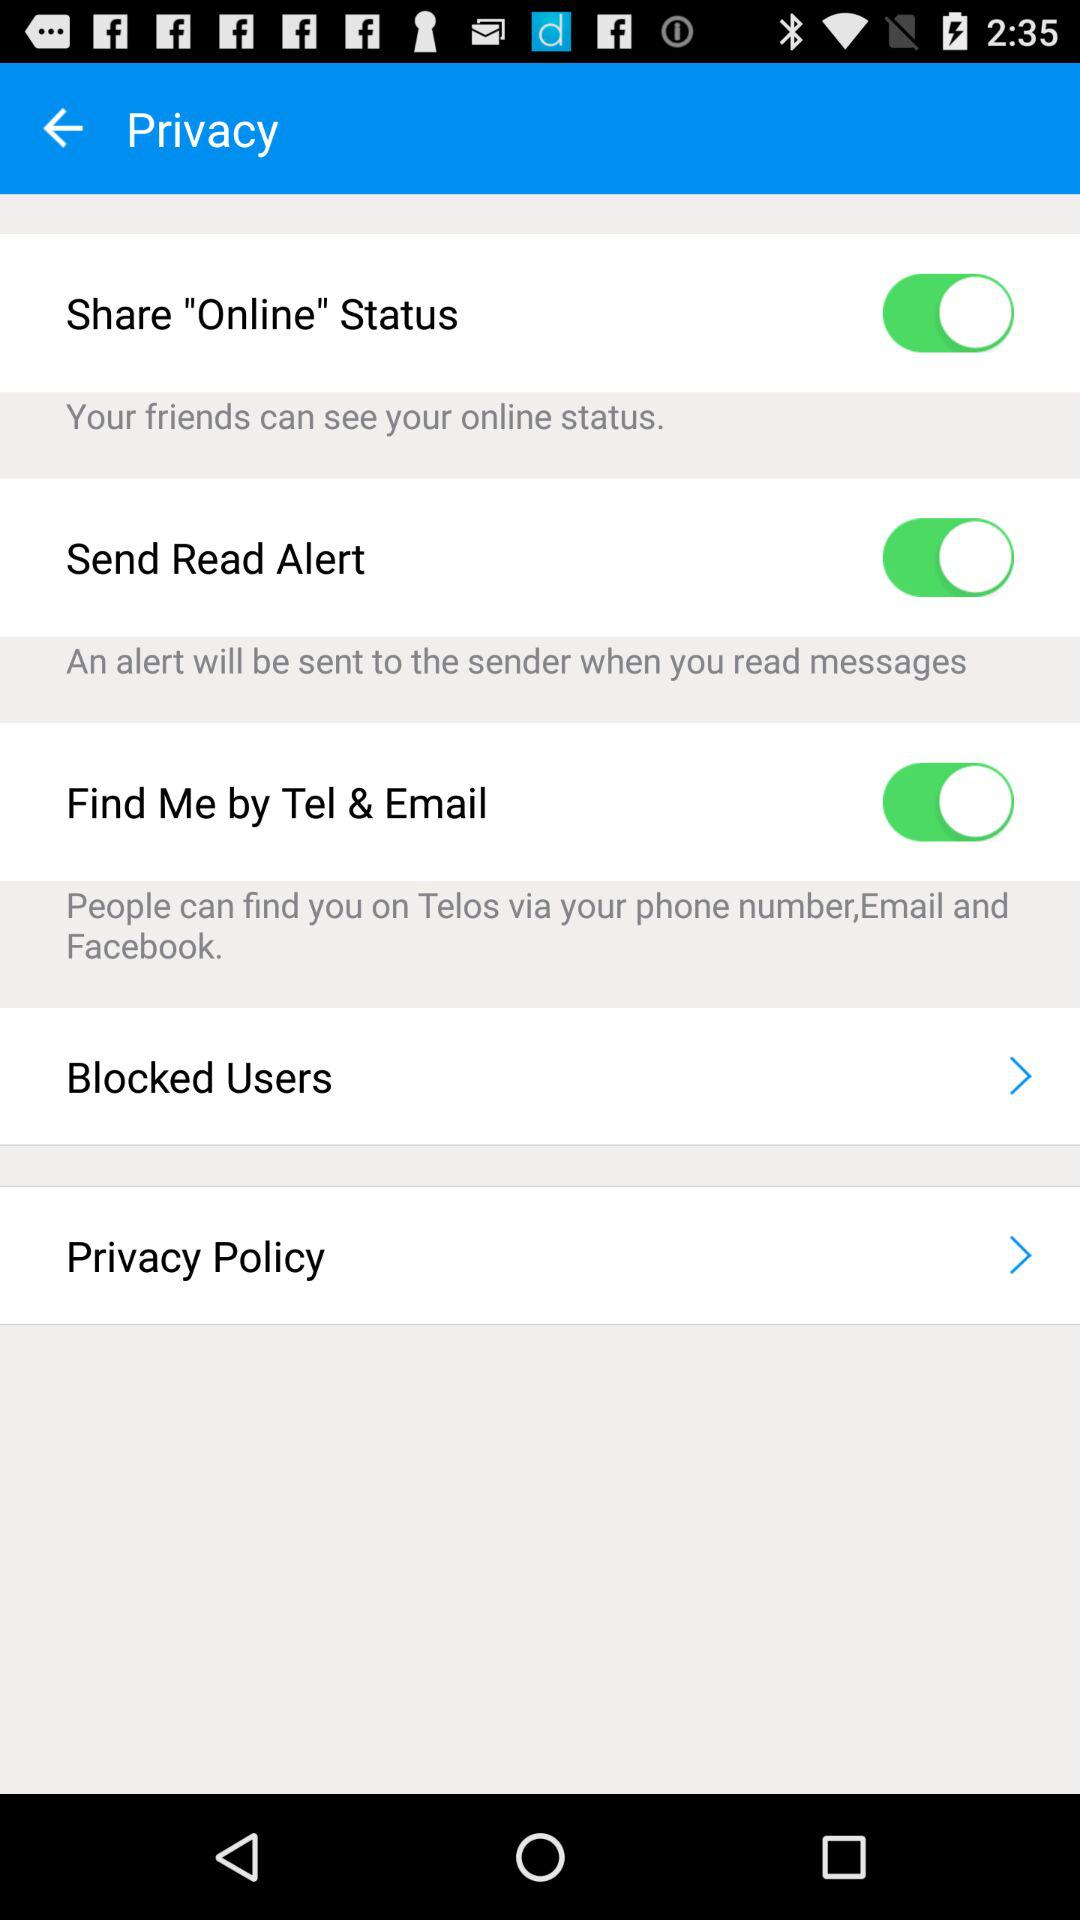When will we get a read alert? You will get read alert when you read messages. 